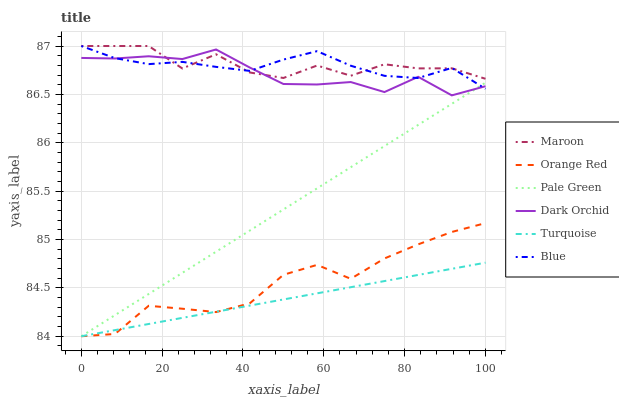Does Turquoise have the minimum area under the curve?
Answer yes or no. Yes. Does Maroon have the maximum area under the curve?
Answer yes or no. Yes. Does Dark Orchid have the minimum area under the curve?
Answer yes or no. No. Does Dark Orchid have the maximum area under the curve?
Answer yes or no. No. Is Pale Green the smoothest?
Answer yes or no. Yes. Is Maroon the roughest?
Answer yes or no. Yes. Is Turquoise the smoothest?
Answer yes or no. No. Is Turquoise the roughest?
Answer yes or no. No. Does Turquoise have the lowest value?
Answer yes or no. Yes. Does Dark Orchid have the lowest value?
Answer yes or no. No. Does Maroon have the highest value?
Answer yes or no. Yes. Does Dark Orchid have the highest value?
Answer yes or no. No. Is Turquoise less than Maroon?
Answer yes or no. Yes. Is Dark Orchid greater than Turquoise?
Answer yes or no. Yes. Does Pale Green intersect Orange Red?
Answer yes or no. Yes. Is Pale Green less than Orange Red?
Answer yes or no. No. Is Pale Green greater than Orange Red?
Answer yes or no. No. Does Turquoise intersect Maroon?
Answer yes or no. No. 